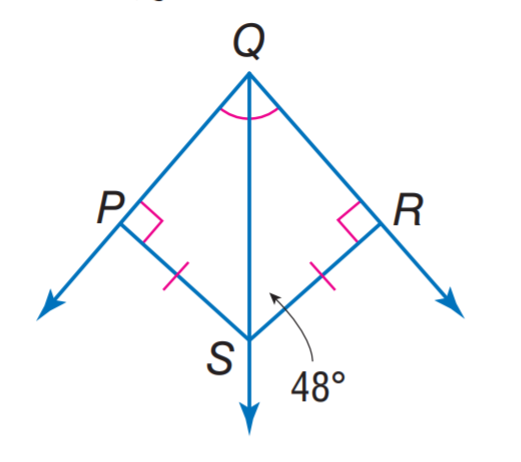Answer the mathemtical geometry problem and directly provide the correct option letter.
Question: Find m \angle P Q S.
Choices: A: 36 B: 42 C: 48 D: 63 B 